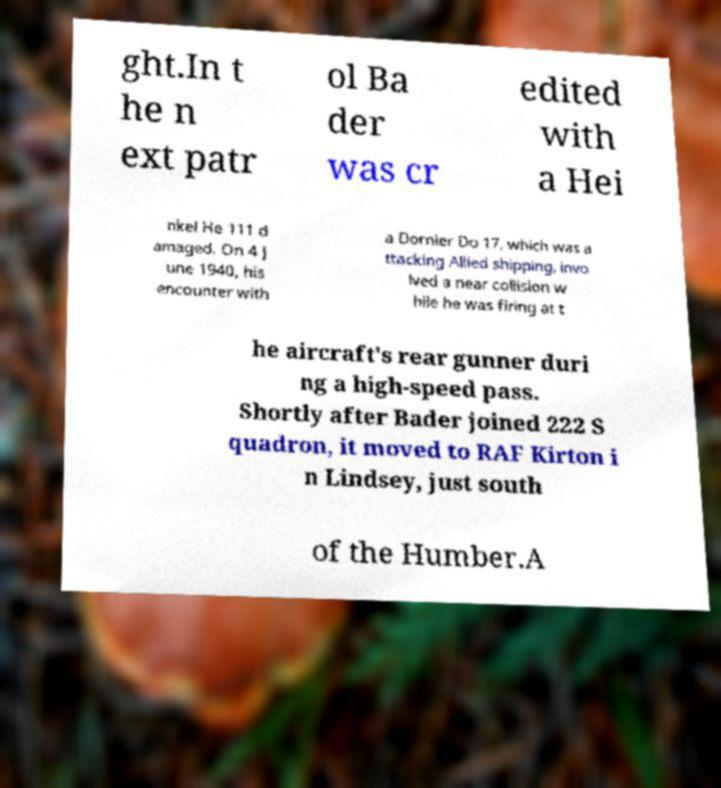There's text embedded in this image that I need extracted. Can you transcribe it verbatim? ght.In t he n ext patr ol Ba der was cr edited with a Hei nkel He 111 d amaged. On 4 J une 1940, his encounter with a Dornier Do 17, which was a ttacking Allied shipping, invo lved a near collision w hile he was firing at t he aircraft's rear gunner duri ng a high-speed pass. Shortly after Bader joined 222 S quadron, it moved to RAF Kirton i n Lindsey, just south of the Humber.A 